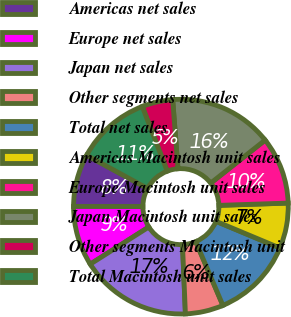Convert chart to OTSL. <chart><loc_0><loc_0><loc_500><loc_500><pie_chart><fcel>Americas net sales<fcel>Europe net sales<fcel>Japan net sales<fcel>Other segments net sales<fcel>Total net sales<fcel>Americas Macintosh unit sales<fcel>Europe Macintosh unit sales<fcel>Japan Macintosh unit sales<fcel>Other segments Macintosh unit<fcel>Total Macintosh unit sales<nl><fcel>7.92%<fcel>9.02%<fcel>16.67%<fcel>5.73%<fcel>12.3%<fcel>6.83%<fcel>10.11%<fcel>15.58%<fcel>4.64%<fcel>11.2%<nl></chart> 